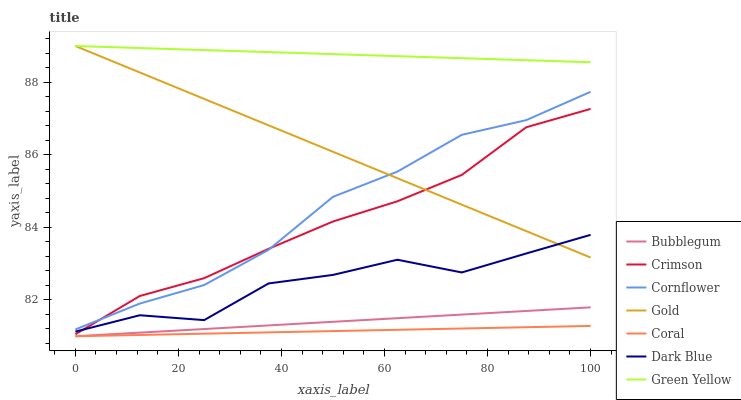Does Coral have the minimum area under the curve?
Answer yes or no. Yes. Does Green Yellow have the maximum area under the curve?
Answer yes or no. Yes. Does Gold have the minimum area under the curve?
Answer yes or no. No. Does Gold have the maximum area under the curve?
Answer yes or no. No. Is Bubblegum the smoothest?
Answer yes or no. Yes. Is Dark Blue the roughest?
Answer yes or no. Yes. Is Gold the smoothest?
Answer yes or no. No. Is Gold the roughest?
Answer yes or no. No. Does Coral have the lowest value?
Answer yes or no. Yes. Does Gold have the lowest value?
Answer yes or no. No. Does Green Yellow have the highest value?
Answer yes or no. Yes. Does Coral have the highest value?
Answer yes or no. No. Is Dark Blue less than Green Yellow?
Answer yes or no. Yes. Is Cornflower greater than Coral?
Answer yes or no. Yes. Does Dark Blue intersect Gold?
Answer yes or no. Yes. Is Dark Blue less than Gold?
Answer yes or no. No. Is Dark Blue greater than Gold?
Answer yes or no. No. Does Dark Blue intersect Green Yellow?
Answer yes or no. No. 